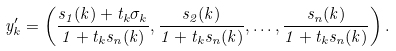<formula> <loc_0><loc_0><loc_500><loc_500>y _ { k } ^ { \prime } = \left ( \frac { s _ { 1 } ( k ) + t _ { k } \sigma _ { k } } { 1 + t _ { k } s _ { n } ( k ) } , \frac { s _ { 2 } ( k ) } { 1 + t _ { k } s _ { n } ( k ) } , \dots , \frac { s _ { n } ( k ) } { 1 + t _ { k } s _ { n } ( k ) } \right ) .</formula> 